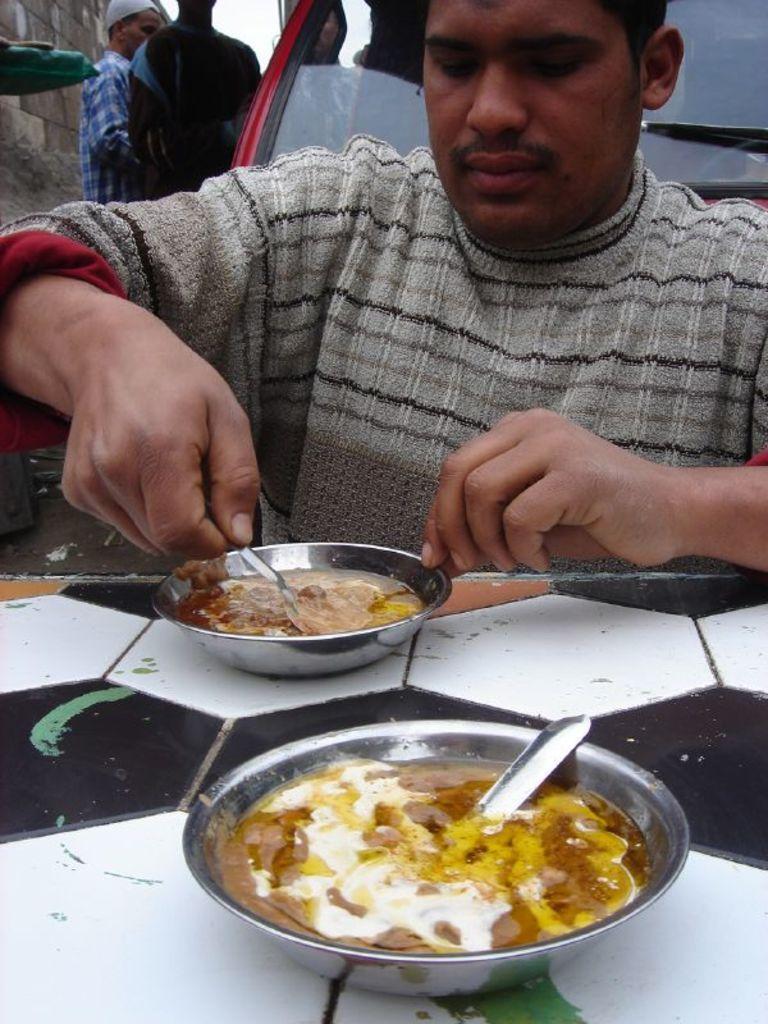In one or two sentences, can you explain what this image depicts? In this image in the foreground there is one person sitting, and in front of him there is a table. On the table there are bowls, and in the bowls there is some food and spoons and it seems that he is mixing the food. And in the background there is one vehicle and some people standing, and there is a wall and some object. 